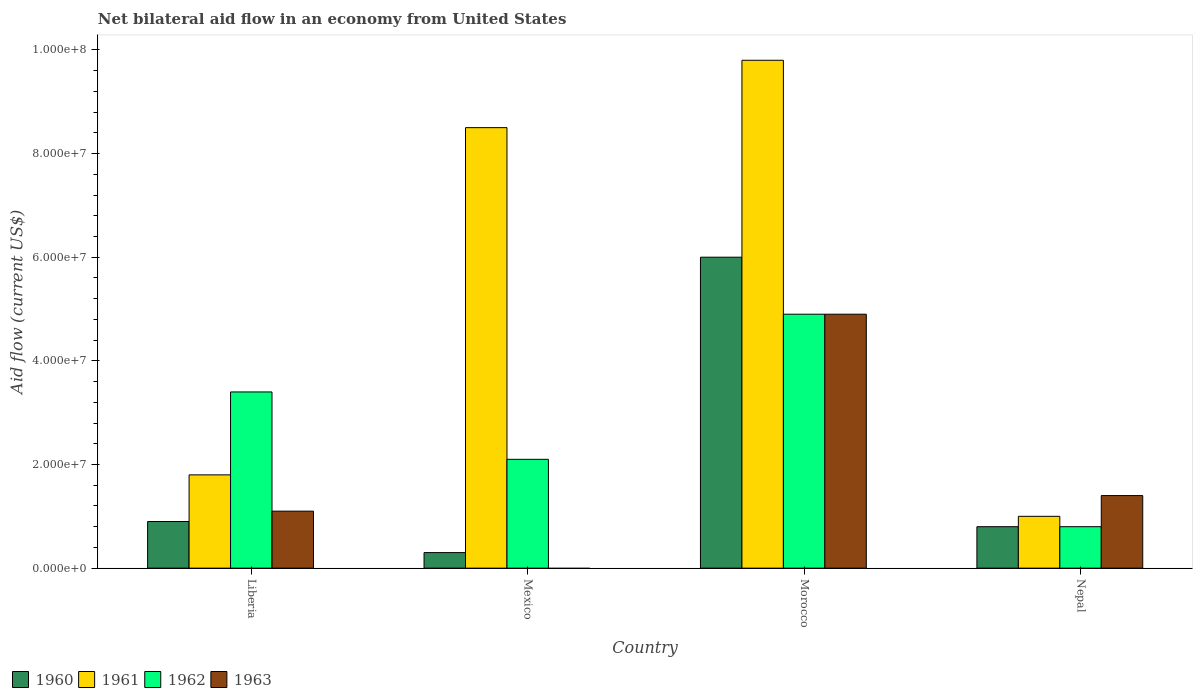How many different coloured bars are there?
Your answer should be compact. 4. How many groups of bars are there?
Your answer should be compact. 4. Are the number of bars per tick equal to the number of legend labels?
Keep it short and to the point. No. What is the label of the 3rd group of bars from the left?
Your response must be concise. Morocco. What is the net bilateral aid flow in 1962 in Liberia?
Ensure brevity in your answer.  3.40e+07. Across all countries, what is the maximum net bilateral aid flow in 1961?
Ensure brevity in your answer.  9.80e+07. Across all countries, what is the minimum net bilateral aid flow in 1963?
Your response must be concise. 0. In which country was the net bilateral aid flow in 1963 maximum?
Provide a short and direct response. Morocco. What is the total net bilateral aid flow in 1961 in the graph?
Offer a terse response. 2.11e+08. What is the difference between the net bilateral aid flow in 1962 in Morocco and that in Nepal?
Keep it short and to the point. 4.10e+07. What is the difference between the net bilateral aid flow in 1961 in Nepal and the net bilateral aid flow in 1962 in Mexico?
Your answer should be compact. -1.10e+07. What is the average net bilateral aid flow in 1961 per country?
Provide a short and direct response. 5.28e+07. What is the difference between the net bilateral aid flow of/in 1962 and net bilateral aid flow of/in 1961 in Mexico?
Ensure brevity in your answer.  -6.40e+07. In how many countries, is the net bilateral aid flow in 1962 greater than 60000000 US$?
Your response must be concise. 0. What is the ratio of the net bilateral aid flow in 1961 in Morocco to that in Nepal?
Offer a terse response. 9.8. Is the net bilateral aid flow in 1960 in Liberia less than that in Nepal?
Your response must be concise. No. Is the difference between the net bilateral aid flow in 1962 in Liberia and Mexico greater than the difference between the net bilateral aid flow in 1961 in Liberia and Mexico?
Provide a short and direct response. Yes. What is the difference between the highest and the second highest net bilateral aid flow in 1963?
Provide a succinct answer. 3.50e+07. What is the difference between the highest and the lowest net bilateral aid flow in 1961?
Your answer should be very brief. 8.80e+07. In how many countries, is the net bilateral aid flow in 1961 greater than the average net bilateral aid flow in 1961 taken over all countries?
Give a very brief answer. 2. Is it the case that in every country, the sum of the net bilateral aid flow in 1960 and net bilateral aid flow in 1963 is greater than the sum of net bilateral aid flow in 1961 and net bilateral aid flow in 1962?
Give a very brief answer. No. How many bars are there?
Your answer should be compact. 15. Are all the bars in the graph horizontal?
Make the answer very short. No. How many countries are there in the graph?
Your answer should be very brief. 4. Are the values on the major ticks of Y-axis written in scientific E-notation?
Offer a terse response. Yes. How many legend labels are there?
Your answer should be compact. 4. How are the legend labels stacked?
Your response must be concise. Horizontal. What is the title of the graph?
Your response must be concise. Net bilateral aid flow in an economy from United States. Does "1962" appear as one of the legend labels in the graph?
Offer a terse response. Yes. What is the Aid flow (current US$) in 1960 in Liberia?
Your answer should be very brief. 9.00e+06. What is the Aid flow (current US$) in 1961 in Liberia?
Give a very brief answer. 1.80e+07. What is the Aid flow (current US$) of 1962 in Liberia?
Your answer should be compact. 3.40e+07. What is the Aid flow (current US$) in 1963 in Liberia?
Your response must be concise. 1.10e+07. What is the Aid flow (current US$) in 1960 in Mexico?
Your answer should be very brief. 3.00e+06. What is the Aid flow (current US$) of 1961 in Mexico?
Your answer should be compact. 8.50e+07. What is the Aid flow (current US$) in 1962 in Mexico?
Ensure brevity in your answer.  2.10e+07. What is the Aid flow (current US$) in 1963 in Mexico?
Your response must be concise. 0. What is the Aid flow (current US$) of 1960 in Morocco?
Provide a succinct answer. 6.00e+07. What is the Aid flow (current US$) in 1961 in Morocco?
Your response must be concise. 9.80e+07. What is the Aid flow (current US$) of 1962 in Morocco?
Your answer should be compact. 4.90e+07. What is the Aid flow (current US$) in 1963 in Morocco?
Offer a terse response. 4.90e+07. What is the Aid flow (current US$) in 1960 in Nepal?
Offer a very short reply. 8.00e+06. What is the Aid flow (current US$) in 1963 in Nepal?
Offer a terse response. 1.40e+07. Across all countries, what is the maximum Aid flow (current US$) of 1960?
Keep it short and to the point. 6.00e+07. Across all countries, what is the maximum Aid flow (current US$) of 1961?
Your answer should be compact. 9.80e+07. Across all countries, what is the maximum Aid flow (current US$) in 1962?
Ensure brevity in your answer.  4.90e+07. Across all countries, what is the maximum Aid flow (current US$) in 1963?
Ensure brevity in your answer.  4.90e+07. Across all countries, what is the minimum Aid flow (current US$) in 1960?
Make the answer very short. 3.00e+06. Across all countries, what is the minimum Aid flow (current US$) in 1961?
Offer a very short reply. 1.00e+07. What is the total Aid flow (current US$) in 1960 in the graph?
Offer a terse response. 8.00e+07. What is the total Aid flow (current US$) of 1961 in the graph?
Make the answer very short. 2.11e+08. What is the total Aid flow (current US$) in 1962 in the graph?
Your answer should be very brief. 1.12e+08. What is the total Aid flow (current US$) in 1963 in the graph?
Make the answer very short. 7.40e+07. What is the difference between the Aid flow (current US$) of 1960 in Liberia and that in Mexico?
Make the answer very short. 6.00e+06. What is the difference between the Aid flow (current US$) of 1961 in Liberia and that in Mexico?
Your answer should be very brief. -6.70e+07. What is the difference between the Aid flow (current US$) in 1962 in Liberia and that in Mexico?
Provide a short and direct response. 1.30e+07. What is the difference between the Aid flow (current US$) in 1960 in Liberia and that in Morocco?
Your response must be concise. -5.10e+07. What is the difference between the Aid flow (current US$) of 1961 in Liberia and that in Morocco?
Provide a succinct answer. -8.00e+07. What is the difference between the Aid flow (current US$) of 1962 in Liberia and that in Morocco?
Provide a succinct answer. -1.50e+07. What is the difference between the Aid flow (current US$) of 1963 in Liberia and that in Morocco?
Your answer should be very brief. -3.80e+07. What is the difference between the Aid flow (current US$) in 1962 in Liberia and that in Nepal?
Your answer should be compact. 2.60e+07. What is the difference between the Aid flow (current US$) in 1963 in Liberia and that in Nepal?
Provide a succinct answer. -3.00e+06. What is the difference between the Aid flow (current US$) of 1960 in Mexico and that in Morocco?
Make the answer very short. -5.70e+07. What is the difference between the Aid flow (current US$) in 1961 in Mexico and that in Morocco?
Your response must be concise. -1.30e+07. What is the difference between the Aid flow (current US$) in 1962 in Mexico and that in Morocco?
Offer a very short reply. -2.80e+07. What is the difference between the Aid flow (current US$) of 1960 in Mexico and that in Nepal?
Your response must be concise. -5.00e+06. What is the difference between the Aid flow (current US$) in 1961 in Mexico and that in Nepal?
Offer a very short reply. 7.50e+07. What is the difference between the Aid flow (current US$) of 1962 in Mexico and that in Nepal?
Your answer should be compact. 1.30e+07. What is the difference between the Aid flow (current US$) of 1960 in Morocco and that in Nepal?
Make the answer very short. 5.20e+07. What is the difference between the Aid flow (current US$) in 1961 in Morocco and that in Nepal?
Offer a terse response. 8.80e+07. What is the difference between the Aid flow (current US$) in 1962 in Morocco and that in Nepal?
Give a very brief answer. 4.10e+07. What is the difference between the Aid flow (current US$) of 1963 in Morocco and that in Nepal?
Provide a short and direct response. 3.50e+07. What is the difference between the Aid flow (current US$) in 1960 in Liberia and the Aid flow (current US$) in 1961 in Mexico?
Keep it short and to the point. -7.60e+07. What is the difference between the Aid flow (current US$) in 1960 in Liberia and the Aid flow (current US$) in 1962 in Mexico?
Your answer should be very brief. -1.20e+07. What is the difference between the Aid flow (current US$) of 1960 in Liberia and the Aid flow (current US$) of 1961 in Morocco?
Ensure brevity in your answer.  -8.90e+07. What is the difference between the Aid flow (current US$) of 1960 in Liberia and the Aid flow (current US$) of 1962 in Morocco?
Offer a very short reply. -4.00e+07. What is the difference between the Aid flow (current US$) of 1960 in Liberia and the Aid flow (current US$) of 1963 in Morocco?
Your answer should be compact. -4.00e+07. What is the difference between the Aid flow (current US$) in 1961 in Liberia and the Aid flow (current US$) in 1962 in Morocco?
Give a very brief answer. -3.10e+07. What is the difference between the Aid flow (current US$) in 1961 in Liberia and the Aid flow (current US$) in 1963 in Morocco?
Give a very brief answer. -3.10e+07. What is the difference between the Aid flow (current US$) in 1962 in Liberia and the Aid flow (current US$) in 1963 in Morocco?
Give a very brief answer. -1.50e+07. What is the difference between the Aid flow (current US$) of 1960 in Liberia and the Aid flow (current US$) of 1961 in Nepal?
Your answer should be very brief. -1.00e+06. What is the difference between the Aid flow (current US$) of 1960 in Liberia and the Aid flow (current US$) of 1962 in Nepal?
Keep it short and to the point. 1.00e+06. What is the difference between the Aid flow (current US$) in 1960 in Liberia and the Aid flow (current US$) in 1963 in Nepal?
Provide a short and direct response. -5.00e+06. What is the difference between the Aid flow (current US$) in 1961 in Liberia and the Aid flow (current US$) in 1962 in Nepal?
Make the answer very short. 1.00e+07. What is the difference between the Aid flow (current US$) in 1961 in Liberia and the Aid flow (current US$) in 1963 in Nepal?
Your response must be concise. 4.00e+06. What is the difference between the Aid flow (current US$) in 1962 in Liberia and the Aid flow (current US$) in 1963 in Nepal?
Ensure brevity in your answer.  2.00e+07. What is the difference between the Aid flow (current US$) of 1960 in Mexico and the Aid flow (current US$) of 1961 in Morocco?
Keep it short and to the point. -9.50e+07. What is the difference between the Aid flow (current US$) of 1960 in Mexico and the Aid flow (current US$) of 1962 in Morocco?
Offer a terse response. -4.60e+07. What is the difference between the Aid flow (current US$) in 1960 in Mexico and the Aid flow (current US$) in 1963 in Morocco?
Make the answer very short. -4.60e+07. What is the difference between the Aid flow (current US$) of 1961 in Mexico and the Aid flow (current US$) of 1962 in Morocco?
Provide a short and direct response. 3.60e+07. What is the difference between the Aid flow (current US$) in 1961 in Mexico and the Aid flow (current US$) in 1963 in Morocco?
Your answer should be very brief. 3.60e+07. What is the difference between the Aid flow (current US$) of 1962 in Mexico and the Aid flow (current US$) of 1963 in Morocco?
Ensure brevity in your answer.  -2.80e+07. What is the difference between the Aid flow (current US$) in 1960 in Mexico and the Aid flow (current US$) in 1961 in Nepal?
Offer a very short reply. -7.00e+06. What is the difference between the Aid flow (current US$) of 1960 in Mexico and the Aid flow (current US$) of 1962 in Nepal?
Give a very brief answer. -5.00e+06. What is the difference between the Aid flow (current US$) of 1960 in Mexico and the Aid flow (current US$) of 1963 in Nepal?
Make the answer very short. -1.10e+07. What is the difference between the Aid flow (current US$) of 1961 in Mexico and the Aid flow (current US$) of 1962 in Nepal?
Provide a succinct answer. 7.70e+07. What is the difference between the Aid flow (current US$) of 1961 in Mexico and the Aid flow (current US$) of 1963 in Nepal?
Provide a succinct answer. 7.10e+07. What is the difference between the Aid flow (current US$) in 1962 in Mexico and the Aid flow (current US$) in 1963 in Nepal?
Give a very brief answer. 7.00e+06. What is the difference between the Aid flow (current US$) in 1960 in Morocco and the Aid flow (current US$) in 1962 in Nepal?
Your answer should be compact. 5.20e+07. What is the difference between the Aid flow (current US$) in 1960 in Morocco and the Aid flow (current US$) in 1963 in Nepal?
Ensure brevity in your answer.  4.60e+07. What is the difference between the Aid flow (current US$) of 1961 in Morocco and the Aid flow (current US$) of 1962 in Nepal?
Provide a short and direct response. 9.00e+07. What is the difference between the Aid flow (current US$) in 1961 in Morocco and the Aid flow (current US$) in 1963 in Nepal?
Provide a succinct answer. 8.40e+07. What is the difference between the Aid flow (current US$) of 1962 in Morocco and the Aid flow (current US$) of 1963 in Nepal?
Give a very brief answer. 3.50e+07. What is the average Aid flow (current US$) of 1960 per country?
Your response must be concise. 2.00e+07. What is the average Aid flow (current US$) of 1961 per country?
Your response must be concise. 5.28e+07. What is the average Aid flow (current US$) in 1962 per country?
Offer a very short reply. 2.80e+07. What is the average Aid flow (current US$) in 1963 per country?
Give a very brief answer. 1.85e+07. What is the difference between the Aid flow (current US$) in 1960 and Aid flow (current US$) in 1961 in Liberia?
Offer a very short reply. -9.00e+06. What is the difference between the Aid flow (current US$) in 1960 and Aid flow (current US$) in 1962 in Liberia?
Keep it short and to the point. -2.50e+07. What is the difference between the Aid flow (current US$) of 1961 and Aid flow (current US$) of 1962 in Liberia?
Offer a terse response. -1.60e+07. What is the difference between the Aid flow (current US$) of 1961 and Aid flow (current US$) of 1963 in Liberia?
Your answer should be very brief. 7.00e+06. What is the difference between the Aid flow (current US$) in 1962 and Aid flow (current US$) in 1963 in Liberia?
Your answer should be compact. 2.30e+07. What is the difference between the Aid flow (current US$) of 1960 and Aid flow (current US$) of 1961 in Mexico?
Offer a very short reply. -8.20e+07. What is the difference between the Aid flow (current US$) in 1960 and Aid flow (current US$) in 1962 in Mexico?
Offer a very short reply. -1.80e+07. What is the difference between the Aid flow (current US$) of 1961 and Aid flow (current US$) of 1962 in Mexico?
Provide a short and direct response. 6.40e+07. What is the difference between the Aid flow (current US$) of 1960 and Aid flow (current US$) of 1961 in Morocco?
Keep it short and to the point. -3.80e+07. What is the difference between the Aid flow (current US$) in 1960 and Aid flow (current US$) in 1962 in Morocco?
Offer a terse response. 1.10e+07. What is the difference between the Aid flow (current US$) of 1960 and Aid flow (current US$) of 1963 in Morocco?
Give a very brief answer. 1.10e+07. What is the difference between the Aid flow (current US$) of 1961 and Aid flow (current US$) of 1962 in Morocco?
Offer a terse response. 4.90e+07. What is the difference between the Aid flow (current US$) of 1961 and Aid flow (current US$) of 1963 in Morocco?
Give a very brief answer. 4.90e+07. What is the difference between the Aid flow (current US$) in 1962 and Aid flow (current US$) in 1963 in Morocco?
Give a very brief answer. 0. What is the difference between the Aid flow (current US$) in 1960 and Aid flow (current US$) in 1962 in Nepal?
Keep it short and to the point. 0. What is the difference between the Aid flow (current US$) of 1960 and Aid flow (current US$) of 1963 in Nepal?
Keep it short and to the point. -6.00e+06. What is the difference between the Aid flow (current US$) in 1961 and Aid flow (current US$) in 1962 in Nepal?
Ensure brevity in your answer.  2.00e+06. What is the difference between the Aid flow (current US$) of 1962 and Aid flow (current US$) of 1963 in Nepal?
Provide a succinct answer. -6.00e+06. What is the ratio of the Aid flow (current US$) of 1960 in Liberia to that in Mexico?
Provide a succinct answer. 3. What is the ratio of the Aid flow (current US$) of 1961 in Liberia to that in Mexico?
Make the answer very short. 0.21. What is the ratio of the Aid flow (current US$) of 1962 in Liberia to that in Mexico?
Make the answer very short. 1.62. What is the ratio of the Aid flow (current US$) of 1960 in Liberia to that in Morocco?
Offer a terse response. 0.15. What is the ratio of the Aid flow (current US$) in 1961 in Liberia to that in Morocco?
Your answer should be compact. 0.18. What is the ratio of the Aid flow (current US$) of 1962 in Liberia to that in Morocco?
Your answer should be compact. 0.69. What is the ratio of the Aid flow (current US$) in 1963 in Liberia to that in Morocco?
Keep it short and to the point. 0.22. What is the ratio of the Aid flow (current US$) in 1961 in Liberia to that in Nepal?
Your answer should be very brief. 1.8. What is the ratio of the Aid flow (current US$) of 1962 in Liberia to that in Nepal?
Your response must be concise. 4.25. What is the ratio of the Aid flow (current US$) in 1963 in Liberia to that in Nepal?
Provide a short and direct response. 0.79. What is the ratio of the Aid flow (current US$) in 1960 in Mexico to that in Morocco?
Give a very brief answer. 0.05. What is the ratio of the Aid flow (current US$) of 1961 in Mexico to that in Morocco?
Give a very brief answer. 0.87. What is the ratio of the Aid flow (current US$) in 1962 in Mexico to that in Morocco?
Your answer should be very brief. 0.43. What is the ratio of the Aid flow (current US$) of 1960 in Mexico to that in Nepal?
Your answer should be very brief. 0.38. What is the ratio of the Aid flow (current US$) of 1962 in Mexico to that in Nepal?
Your answer should be very brief. 2.62. What is the ratio of the Aid flow (current US$) of 1960 in Morocco to that in Nepal?
Your answer should be compact. 7.5. What is the ratio of the Aid flow (current US$) of 1962 in Morocco to that in Nepal?
Provide a short and direct response. 6.12. What is the ratio of the Aid flow (current US$) of 1963 in Morocco to that in Nepal?
Keep it short and to the point. 3.5. What is the difference between the highest and the second highest Aid flow (current US$) in 1960?
Give a very brief answer. 5.10e+07. What is the difference between the highest and the second highest Aid flow (current US$) of 1961?
Make the answer very short. 1.30e+07. What is the difference between the highest and the second highest Aid flow (current US$) in 1962?
Offer a very short reply. 1.50e+07. What is the difference between the highest and the second highest Aid flow (current US$) in 1963?
Offer a very short reply. 3.50e+07. What is the difference between the highest and the lowest Aid flow (current US$) of 1960?
Offer a terse response. 5.70e+07. What is the difference between the highest and the lowest Aid flow (current US$) in 1961?
Your answer should be compact. 8.80e+07. What is the difference between the highest and the lowest Aid flow (current US$) in 1962?
Ensure brevity in your answer.  4.10e+07. What is the difference between the highest and the lowest Aid flow (current US$) in 1963?
Offer a terse response. 4.90e+07. 